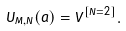Convert formula to latex. <formula><loc_0><loc_0><loc_500><loc_500>U _ { M , N } ( a ) = V ^ { [ N = 2 ] } .</formula> 